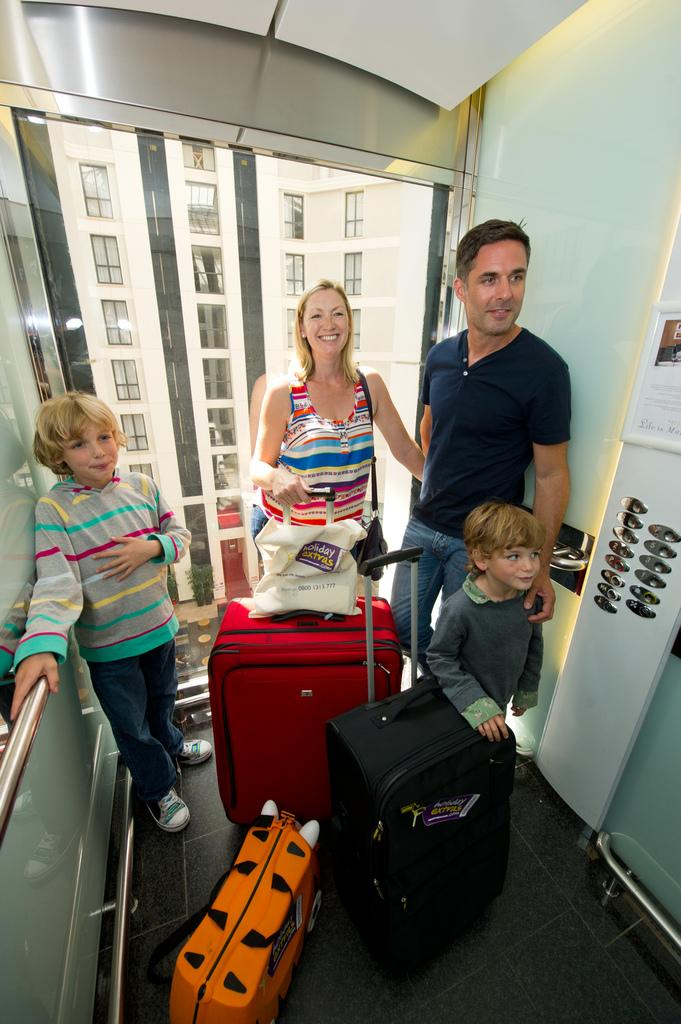What are the people in the image carrying? The people in the image are carrying luggage. Where are the people located in the image? They are in a lift. What can be seen behind the people in the image? There is a glass wall behind them. What might be used to control the lift's movement? There are silver buttons on the left side of the image. What type of holiday is the group planning based on the image? There is no information in the image to suggest that the group is planning a holiday. How far can the people stretch in the image? The image does not show the people stretching, so it is impossible to determine how far they can stretch. 